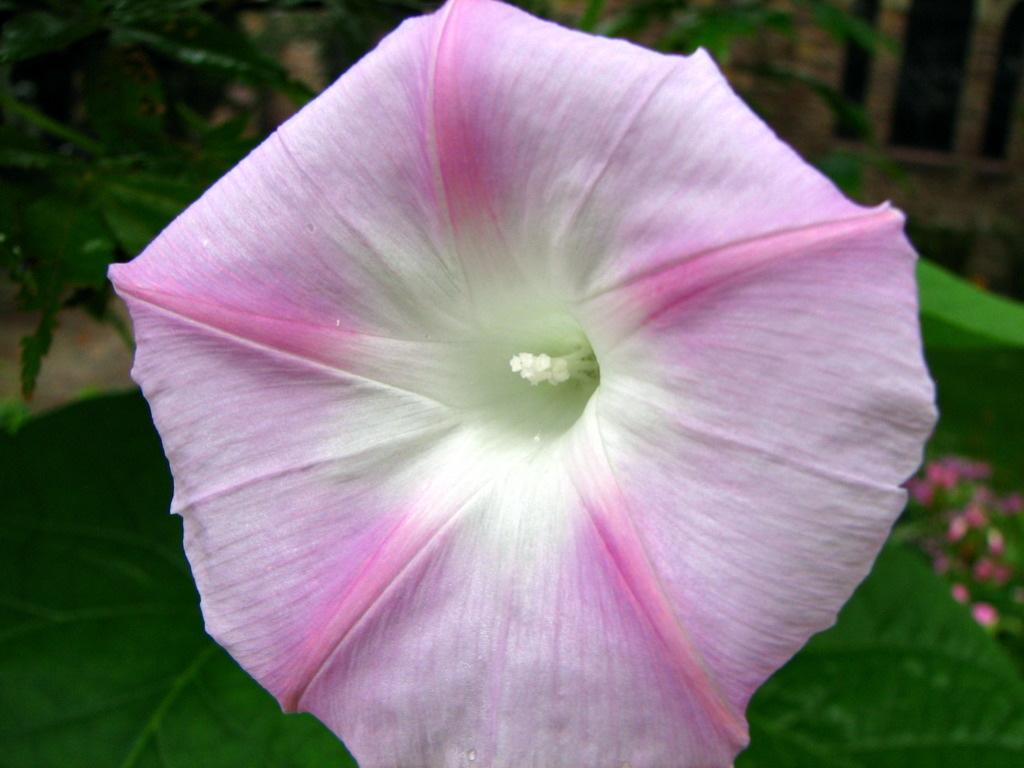What type of living organisms can be seen in the image? Flowers and plants can be seen in the image. Can you describe the specific types of plants in the image? Unfortunately, the provided facts do not specify the types of plants in the image. What type of country is depicted in the image? There is no country depicted in the image; it features flowers and plants. How many buns are visible in the image? There are no buns present in the image. Can you tell me how many dogs are visible in the image? There are no dogs present in the image. 